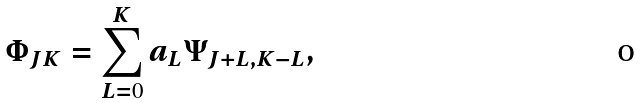Convert formula to latex. <formula><loc_0><loc_0><loc_500><loc_500>\Phi _ { J K } = \sum _ { L = 0 } ^ { K } a _ { L } \Psi _ { J + L , K - L } ,</formula> 